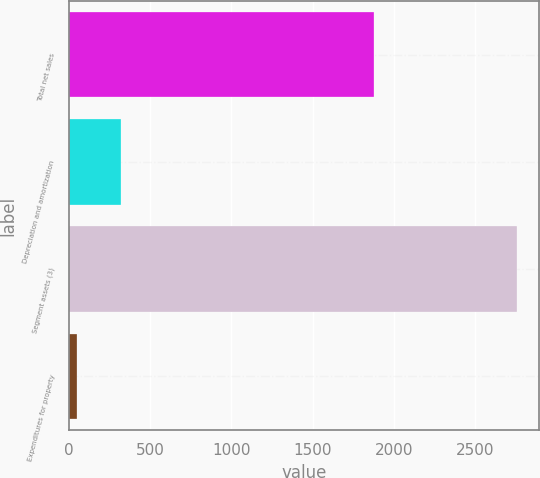<chart> <loc_0><loc_0><loc_500><loc_500><bar_chart><fcel>Total net sales<fcel>Depreciation and amortization<fcel>Segment assets (3)<fcel>Expenditures for property<nl><fcel>1875<fcel>321.8<fcel>2759<fcel>51<nl></chart> 